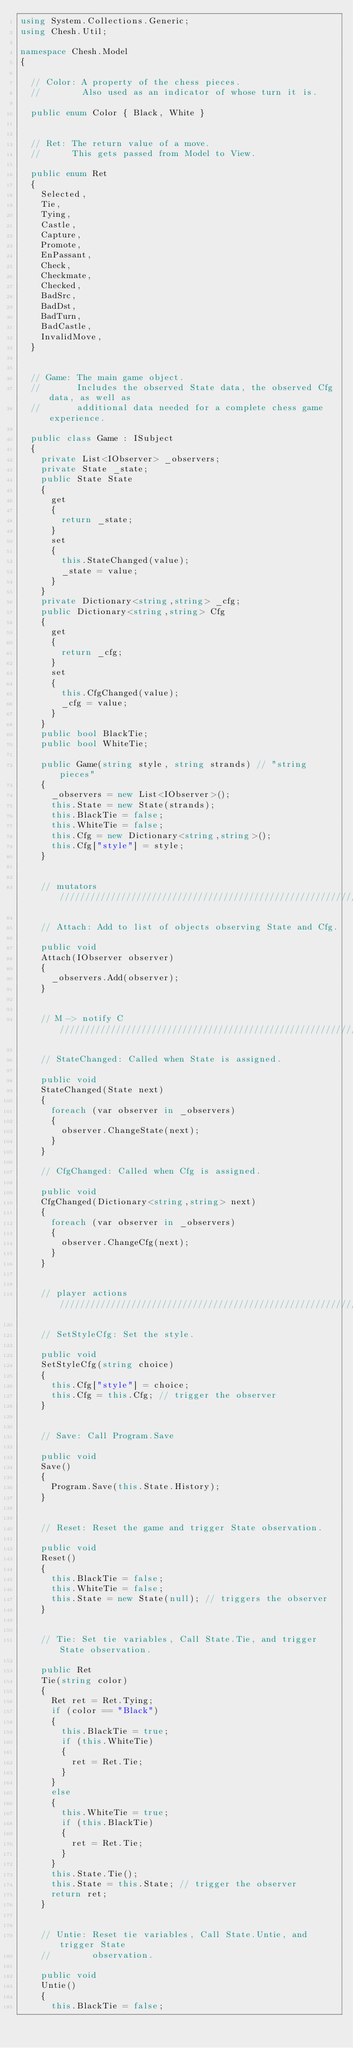Convert code to text. <code><loc_0><loc_0><loc_500><loc_500><_C#_>using System.Collections.Generic;
using Chesh.Util;

namespace Chesh.Model
{

  // Color: A property of the chess pieces.
  //        Also used as an indicator of whose turn it is.

  public enum Color { Black, White }


  // Ret: The return value of a move.
  //      This gets passed from Model to View.

  public enum Ret
  {
    Selected,
    Tie,
    Tying,
    Castle,
    Capture,
    Promote,
    EnPassant,
    Check,
    Checkmate,
    Checked,
    BadSrc,
    BadDst,
    BadTurn,
    BadCastle,
    InvalidMove,
  }


  // Game: The main game object.
  //       Includes the observed State data, the observed Cfg data, as well as
  //       additional data needed for a complete chess game experience.

  public class Game : ISubject
  {
    private List<IObserver> _observers;
    private State _state;
    public State State
    {
      get
      {
        return _state;
      }
      set
      {
        this.StateChanged(value);
        _state = value;
      }
    }
    private Dictionary<string,string> _cfg;
    public Dictionary<string,string> Cfg
    {
      get
      {
        return _cfg;
      }
      set
      {
        this.CfgChanged(value);
        _cfg = value;
      }
    }
    public bool BlackTie;
    public bool WhiteTie;

    public Game(string style, string strands) // "string pieces"
    {
      _observers = new List<IObserver>();
      this.State = new State(strands);
      this.BlackTie = false;
      this.WhiteTie = false;
      this.Cfg = new Dictionary<string,string>();
      this.Cfg["style"] = style;
    }


    // mutators ////////////////////////////////////////////////////////////////

    // Attach: Add to list of objects observing State and Cfg.

    public void
    Attach(IObserver observer)
    {
      _observers.Add(observer);
    }


    // M -> notify C ///////////////////////////////////////////////////////////

    // StateChanged: Called when State is assigned.

    public void
    StateChanged(State next)
    {
      foreach (var observer in _observers)
      {
        observer.ChangeState(next);
      }
    }

    // CfgChanged: Called when Cfg is assigned.

    public void
    CfgChanged(Dictionary<string,string> next)
    {
      foreach (var observer in _observers)
      {
        observer.ChangeCfg(next);
      }
    }


    // player actions //////////////////////////////////////////////////////////

    // SetStyleCfg: Set the style.

    public void
    SetStyleCfg(string choice)
    {
      this.Cfg["style"] = choice;
      this.Cfg = this.Cfg; // trigger the observer
    }


    // Save: Call Program.Save

    public void
    Save()
    {
      Program.Save(this.State.History);
    }


    // Reset: Reset the game and trigger State observation.

    public void
    Reset()
    {
      this.BlackTie = false;
      this.WhiteTie = false;
      this.State = new State(null); // triggers the observer
    }


    // Tie: Set tie variables, Call State.Tie, and trigger State observation.

    public Ret
    Tie(string color)
    {
      Ret ret = Ret.Tying;
      if (color == "Black")
      {
        this.BlackTie = true;
        if (this.WhiteTie)
        {
          ret = Ret.Tie;
        }
      }
      else
      {
        this.WhiteTie = true;
        if (this.BlackTie)
        {
          ret = Ret.Tie;
        }
      }
      this.State.Tie();
      this.State = this.State; // trigger the observer
      return ret;
    }


    // Untie: Reset tie variables, Call State.Untie, and trigger State
    //        observation.

    public void
    Untie()
    {
      this.BlackTie = false;</code> 